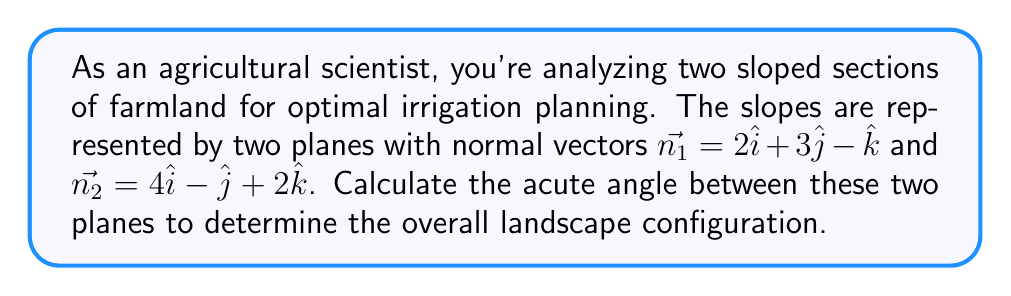Help me with this question. To find the angle between two planes, we can use the angle between their normal vectors. The formula for the angle $\theta$ between two vectors $\vec{a}$ and $\vec{b}$ is:

$$\cos \theta = \frac{\vec{a} \cdot \vec{b}}{|\vec{a}||\vec{b}|}$$

Step 1: Calculate the dot product of the normal vectors.
$$\vec{n_1} \cdot \vec{n_2} = (2)(4) + (3)(-1) + (-1)(2) = 8 - 3 - 2 = 3$$

Step 2: Calculate the magnitudes of the normal vectors.
$$|\vec{n_1}| = \sqrt{2^2 + 3^2 + (-1)^2} = \sqrt{4 + 9 + 1} = \sqrt{14}$$
$$|\vec{n_2}| = \sqrt{4^2 + (-1)^2 + 2^2} = \sqrt{16 + 1 + 4} = \sqrt{21}$$

Step 3: Apply the formula to find $\cos \theta$.
$$\cos \theta = \frac{3}{\sqrt{14}\sqrt{21}}$$

Step 4: Take the inverse cosine (arccos) to find $\theta$.
$$\theta = \arccos\left(\frac{3}{\sqrt{14}\sqrt{21}}\right)$$

Step 5: Convert to degrees.
$$\theta = \arccos\left(\frac{3}{\sqrt{14}\sqrt{21}}\right) \cdot \frac{180^{\circ}}{\pi} \approx 79.92^{\circ}$$
Answer: $79.92^{\circ}$ 